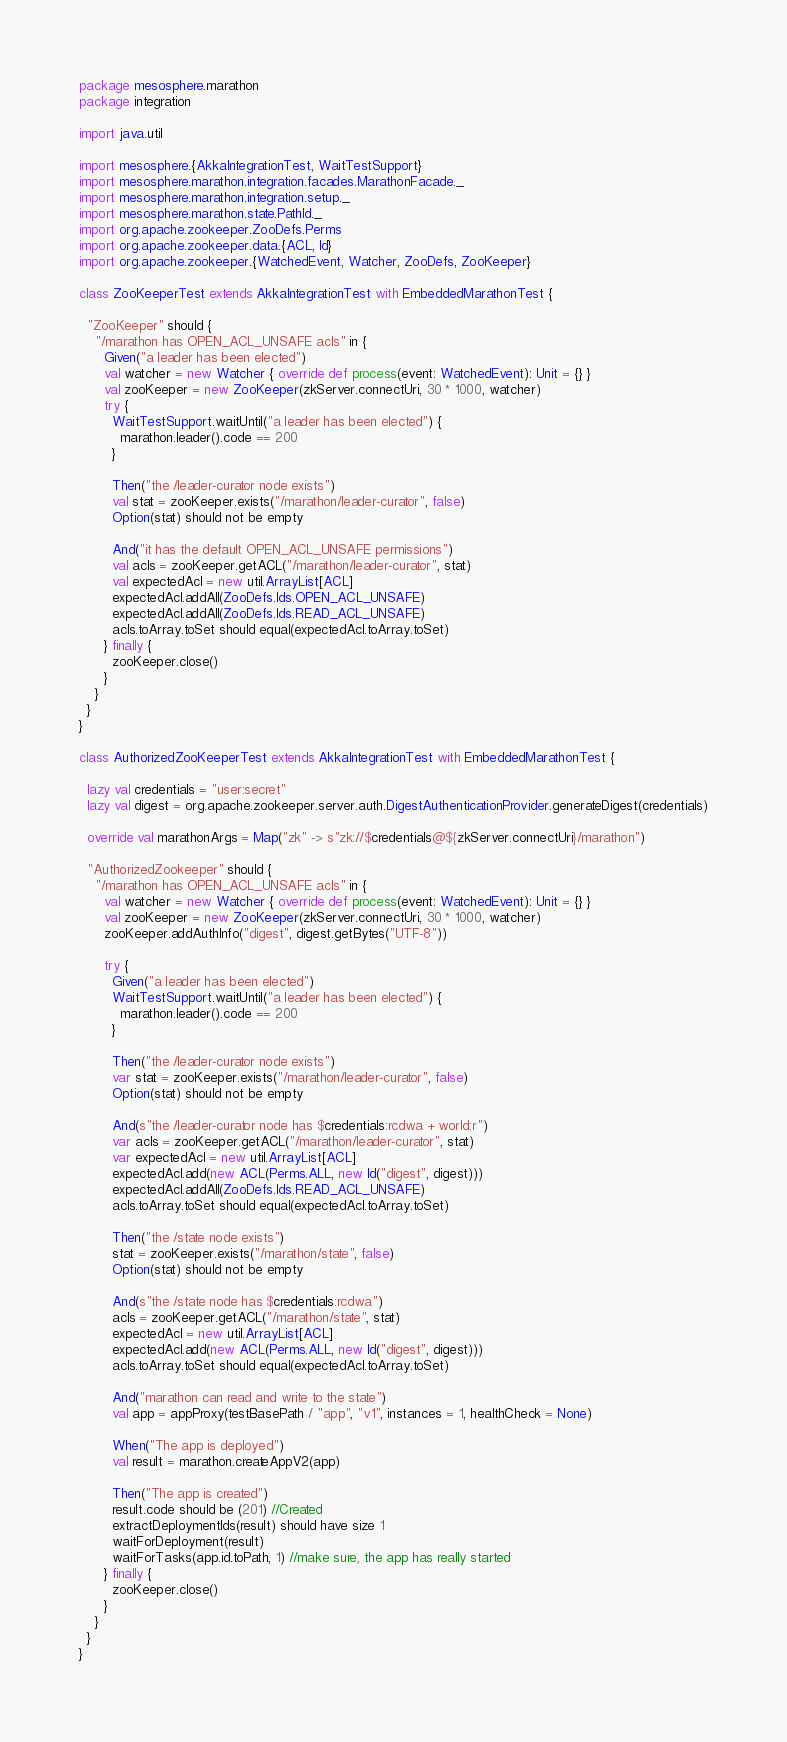Convert code to text. <code><loc_0><loc_0><loc_500><loc_500><_Scala_>package mesosphere.marathon
package integration

import java.util

import mesosphere.{AkkaIntegrationTest, WaitTestSupport}
import mesosphere.marathon.integration.facades.MarathonFacade._
import mesosphere.marathon.integration.setup._
import mesosphere.marathon.state.PathId._
import org.apache.zookeeper.ZooDefs.Perms
import org.apache.zookeeper.data.{ACL, Id}
import org.apache.zookeeper.{WatchedEvent, Watcher, ZooDefs, ZooKeeper}

class ZooKeeperTest extends AkkaIntegrationTest with EmbeddedMarathonTest {

  "ZooKeeper" should {
    "/marathon has OPEN_ACL_UNSAFE acls" in {
      Given("a leader has been elected")
      val watcher = new Watcher { override def process(event: WatchedEvent): Unit = {} }
      val zooKeeper = new ZooKeeper(zkServer.connectUri, 30 * 1000, watcher)
      try {
        WaitTestSupport.waitUntil("a leader has been elected") {
          marathon.leader().code == 200
        }

        Then("the /leader-curator node exists")
        val stat = zooKeeper.exists("/marathon/leader-curator", false)
        Option(stat) should not be empty

        And("it has the default OPEN_ACL_UNSAFE permissions")
        val acls = zooKeeper.getACL("/marathon/leader-curator", stat)
        val expectedAcl = new util.ArrayList[ACL]
        expectedAcl.addAll(ZooDefs.Ids.OPEN_ACL_UNSAFE)
        expectedAcl.addAll(ZooDefs.Ids.READ_ACL_UNSAFE)
        acls.toArray.toSet should equal(expectedAcl.toArray.toSet)
      } finally {
        zooKeeper.close()
      }
    }
  }
}

class AuthorizedZooKeeperTest extends AkkaIntegrationTest with EmbeddedMarathonTest {

  lazy val credentials = "user:secret"
  lazy val digest = org.apache.zookeeper.server.auth.DigestAuthenticationProvider.generateDigest(credentials)

  override val marathonArgs = Map("zk" -> s"zk://$credentials@${zkServer.connectUri}/marathon")

  "AuthorizedZookeeper" should {
    "/marathon has OPEN_ACL_UNSAFE acls" in {
      val watcher = new Watcher { override def process(event: WatchedEvent): Unit = {} }
      val zooKeeper = new ZooKeeper(zkServer.connectUri, 30 * 1000, watcher)
      zooKeeper.addAuthInfo("digest", digest.getBytes("UTF-8"))

      try {
        Given("a leader has been elected")
        WaitTestSupport.waitUntil("a leader has been elected") {
          marathon.leader().code == 200
        }

        Then("the /leader-curator node exists")
        var stat = zooKeeper.exists("/marathon/leader-curator", false)
        Option(stat) should not be empty

        And(s"the /leader-curator node has $credentials:rcdwa + world:r")
        var acls = zooKeeper.getACL("/marathon/leader-curator", stat)
        var expectedAcl = new util.ArrayList[ACL]
        expectedAcl.add(new ACL(Perms.ALL, new Id("digest", digest)))
        expectedAcl.addAll(ZooDefs.Ids.READ_ACL_UNSAFE)
        acls.toArray.toSet should equal(expectedAcl.toArray.toSet)

        Then("the /state node exists")
        stat = zooKeeper.exists("/marathon/state", false)
        Option(stat) should not be empty

        And(s"the /state node has $credentials:rcdwa")
        acls = zooKeeper.getACL("/marathon/state", stat)
        expectedAcl = new util.ArrayList[ACL]
        expectedAcl.add(new ACL(Perms.ALL, new Id("digest", digest)))
        acls.toArray.toSet should equal(expectedAcl.toArray.toSet)

        And("marathon can read and write to the state")
        val app = appProxy(testBasePath / "app", "v1", instances = 1, healthCheck = None)

        When("The app is deployed")
        val result = marathon.createAppV2(app)

        Then("The app is created")
        result.code should be (201) //Created
        extractDeploymentIds(result) should have size 1
        waitForDeployment(result)
        waitForTasks(app.id.toPath, 1) //make sure, the app has really started
      } finally {
        zooKeeper.close()
      }
    }
  }
}
</code> 